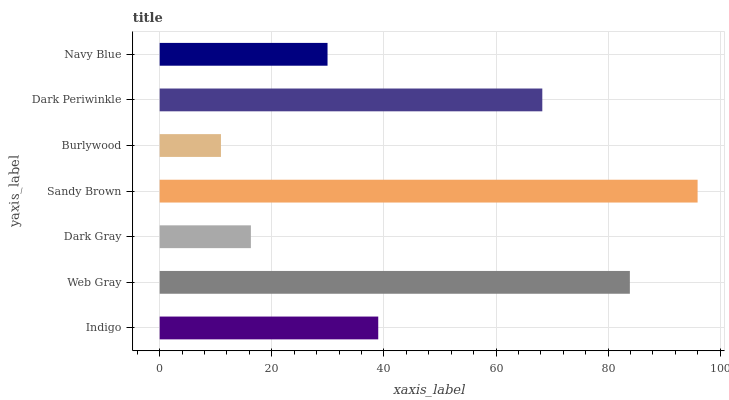Is Burlywood the minimum?
Answer yes or no. Yes. Is Sandy Brown the maximum?
Answer yes or no. Yes. Is Web Gray the minimum?
Answer yes or no. No. Is Web Gray the maximum?
Answer yes or no. No. Is Web Gray greater than Indigo?
Answer yes or no. Yes. Is Indigo less than Web Gray?
Answer yes or no. Yes. Is Indigo greater than Web Gray?
Answer yes or no. No. Is Web Gray less than Indigo?
Answer yes or no. No. Is Indigo the high median?
Answer yes or no. Yes. Is Indigo the low median?
Answer yes or no. Yes. Is Burlywood the high median?
Answer yes or no. No. Is Web Gray the low median?
Answer yes or no. No. 